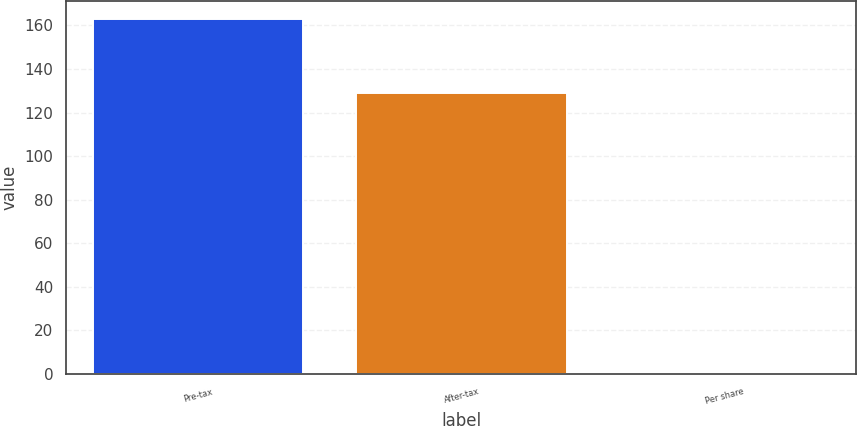Convert chart to OTSL. <chart><loc_0><loc_0><loc_500><loc_500><bar_chart><fcel>Pre-tax<fcel>After-tax<fcel>Per share<nl><fcel>163<fcel>129<fcel>0.08<nl></chart> 